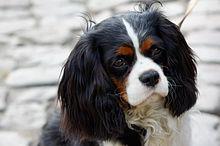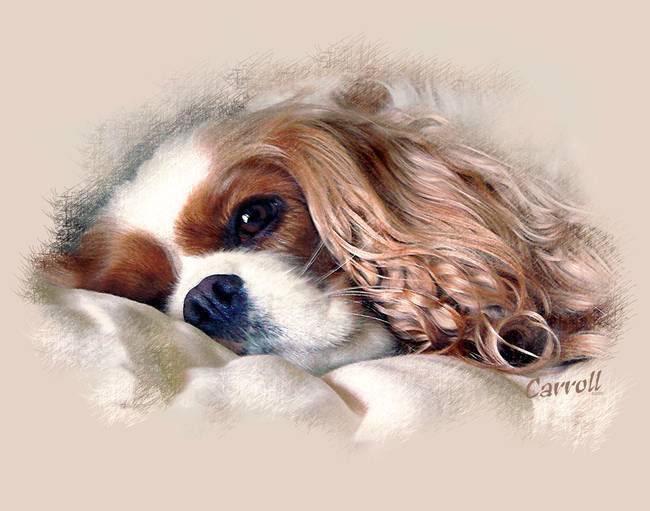The first image is the image on the left, the second image is the image on the right. Analyze the images presented: Is the assertion "There are 2 dogs." valid? Answer yes or no. Yes. The first image is the image on the left, the second image is the image on the right. Evaluate the accuracy of this statement regarding the images: "Each image depicts a single spaniel dog, and the dogs on the right and left have different fur coloring.". Is it true? Answer yes or no. Yes. 